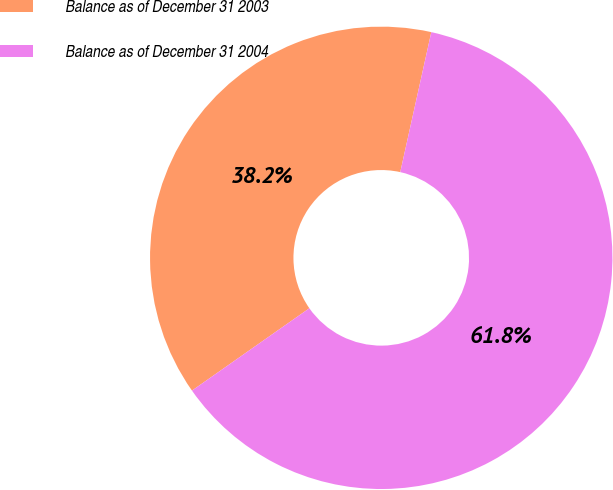Convert chart. <chart><loc_0><loc_0><loc_500><loc_500><pie_chart><fcel>Balance as of December 31 2003<fcel>Balance as of December 31 2004<nl><fcel>38.21%<fcel>61.79%<nl></chart> 